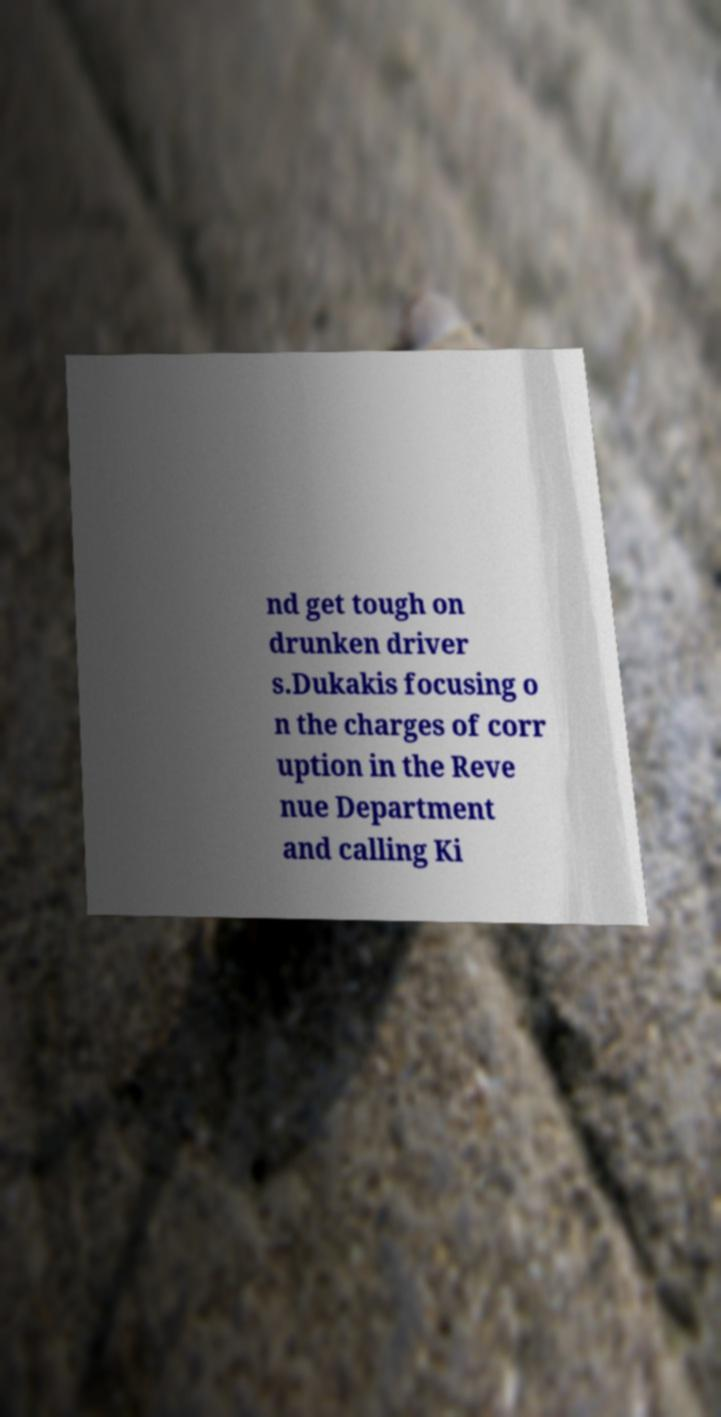Can you accurately transcribe the text from the provided image for me? nd get tough on drunken driver s.Dukakis focusing o n the charges of corr uption in the Reve nue Department and calling Ki 